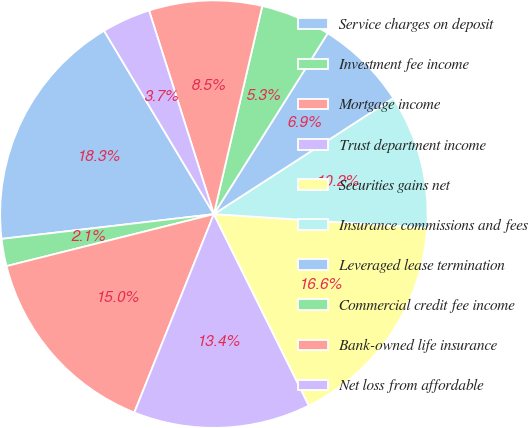Convert chart. <chart><loc_0><loc_0><loc_500><loc_500><pie_chart><fcel>Service charges on deposit<fcel>Investment fee income<fcel>Mortgage income<fcel>Trust department income<fcel>Securities gains net<fcel>Insurance commissions and fees<fcel>Leveraged lease termination<fcel>Commercial credit fee income<fcel>Bank-owned life insurance<fcel>Net loss from affordable<nl><fcel>18.26%<fcel>2.06%<fcel>15.02%<fcel>13.4%<fcel>16.64%<fcel>10.16%<fcel>6.92%<fcel>5.3%<fcel>8.54%<fcel>3.68%<nl></chart> 